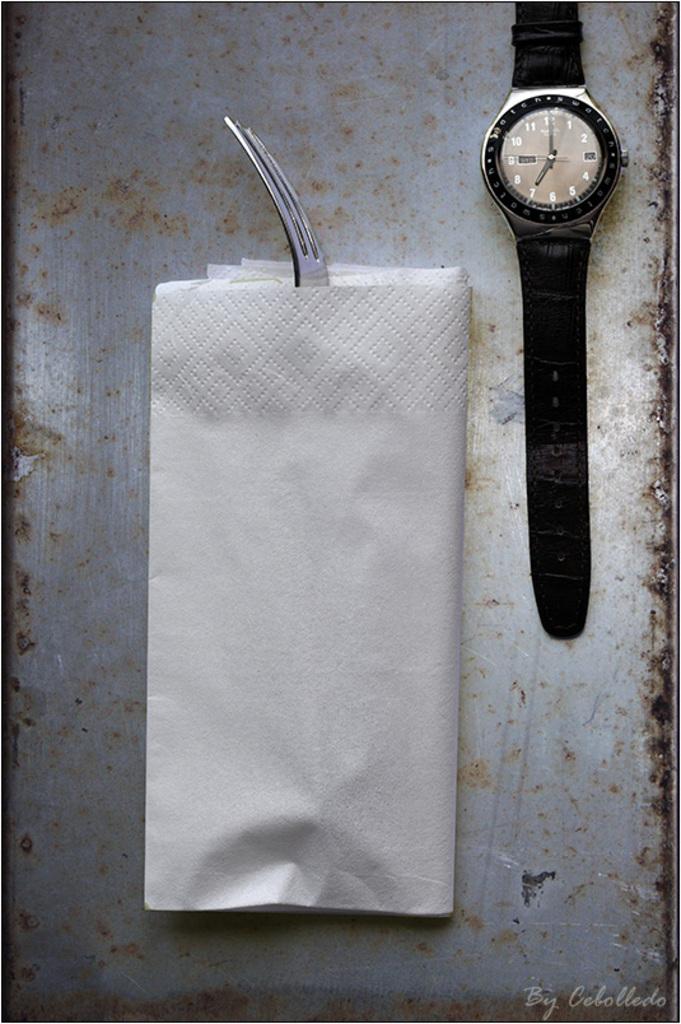What is the time on the watch?
Offer a terse response. 7:00. 